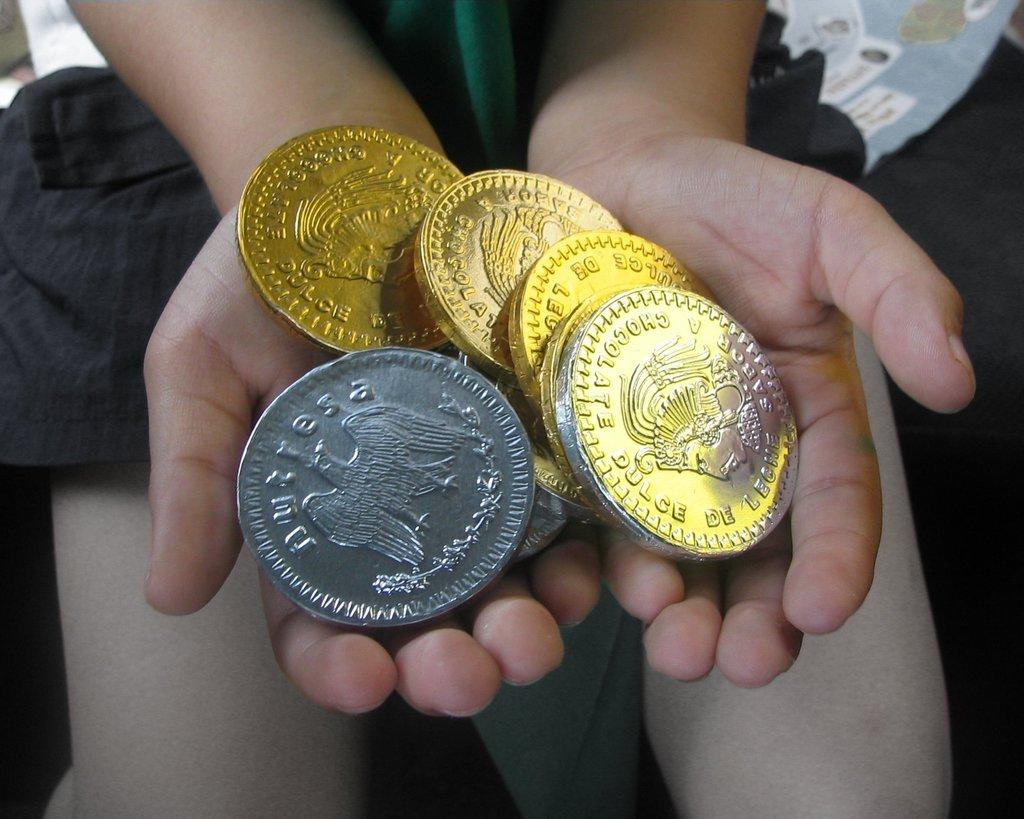What is the main subject of the image? There is a person in the image. What is the person holding in the image? The person is holding coins in the image. Where are the coins located in relation to the person? The coins are in the center of the image. What type of rice can be seen growing in the image? There is no rice present in the image; it features a person holding coins. How many toes can be seen on the person's feet in the image? The image does not show the person's feet, so it is not possible to determine the number of toes. 